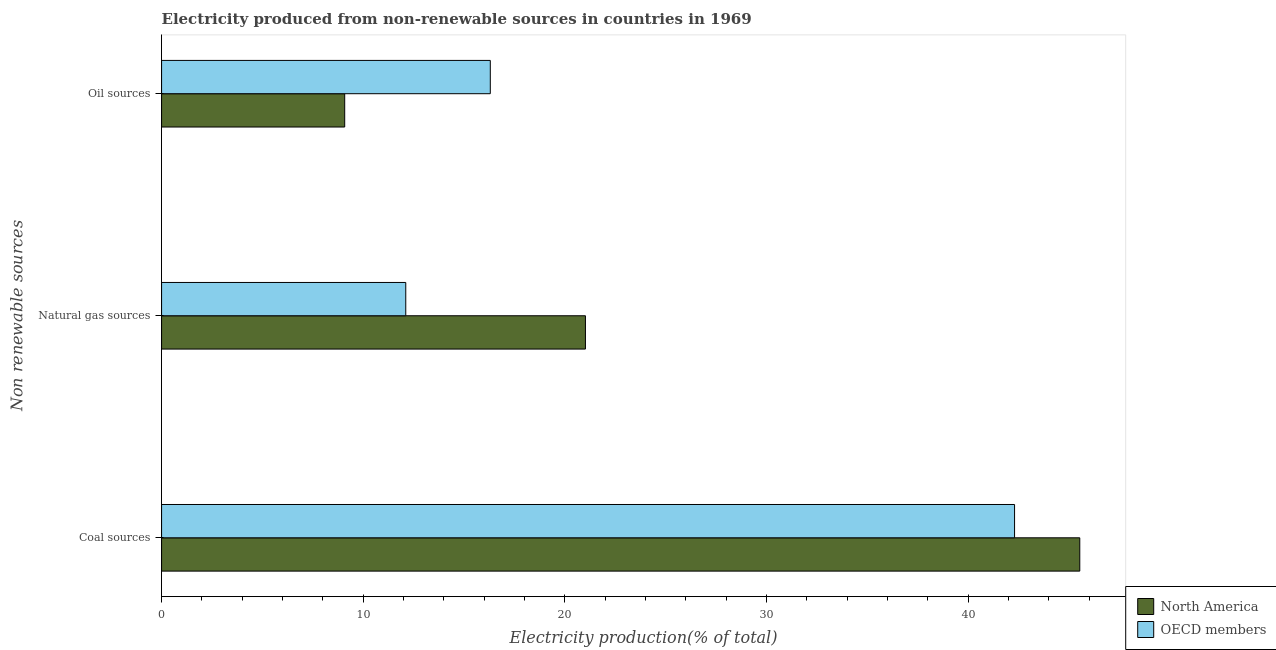How many groups of bars are there?
Offer a terse response. 3. What is the label of the 3rd group of bars from the top?
Offer a terse response. Coal sources. What is the percentage of electricity produced by oil sources in OECD members?
Make the answer very short. 16.3. Across all countries, what is the maximum percentage of electricity produced by coal?
Keep it short and to the point. 45.53. Across all countries, what is the minimum percentage of electricity produced by oil sources?
Make the answer very short. 9.08. What is the total percentage of electricity produced by oil sources in the graph?
Ensure brevity in your answer.  25.38. What is the difference between the percentage of electricity produced by oil sources in North America and that in OECD members?
Your response must be concise. -7.22. What is the difference between the percentage of electricity produced by oil sources in OECD members and the percentage of electricity produced by natural gas in North America?
Provide a short and direct response. -4.72. What is the average percentage of electricity produced by natural gas per country?
Give a very brief answer. 16.56. What is the difference between the percentage of electricity produced by oil sources and percentage of electricity produced by natural gas in OECD members?
Provide a short and direct response. 4.19. In how many countries, is the percentage of electricity produced by oil sources greater than 12 %?
Offer a very short reply. 1. What is the ratio of the percentage of electricity produced by oil sources in OECD members to that in North America?
Ensure brevity in your answer.  1.8. Is the percentage of electricity produced by coal in OECD members less than that in North America?
Ensure brevity in your answer.  Yes. What is the difference between the highest and the second highest percentage of electricity produced by coal?
Make the answer very short. 3.23. What is the difference between the highest and the lowest percentage of electricity produced by oil sources?
Your answer should be compact. 7.22. In how many countries, is the percentage of electricity produced by coal greater than the average percentage of electricity produced by coal taken over all countries?
Offer a terse response. 1. Is the sum of the percentage of electricity produced by oil sources in North America and OECD members greater than the maximum percentage of electricity produced by natural gas across all countries?
Offer a very short reply. Yes. What does the 1st bar from the top in Oil sources represents?
Your response must be concise. OECD members. How many bars are there?
Provide a succinct answer. 6. How many countries are there in the graph?
Your answer should be compact. 2. What is the difference between two consecutive major ticks on the X-axis?
Your answer should be very brief. 10. Does the graph contain grids?
Make the answer very short. No. Where does the legend appear in the graph?
Offer a terse response. Bottom right. How many legend labels are there?
Your answer should be compact. 2. What is the title of the graph?
Your response must be concise. Electricity produced from non-renewable sources in countries in 1969. Does "Central Europe" appear as one of the legend labels in the graph?
Give a very brief answer. No. What is the label or title of the X-axis?
Ensure brevity in your answer.  Electricity production(% of total). What is the label or title of the Y-axis?
Make the answer very short. Non renewable sources. What is the Electricity production(% of total) of North America in Coal sources?
Provide a short and direct response. 45.53. What is the Electricity production(% of total) in OECD members in Coal sources?
Keep it short and to the point. 42.3. What is the Electricity production(% of total) in North America in Natural gas sources?
Your answer should be very brief. 21.02. What is the Electricity production(% of total) of OECD members in Natural gas sources?
Make the answer very short. 12.11. What is the Electricity production(% of total) in North America in Oil sources?
Offer a terse response. 9.08. What is the Electricity production(% of total) of OECD members in Oil sources?
Make the answer very short. 16.3. Across all Non renewable sources, what is the maximum Electricity production(% of total) in North America?
Provide a succinct answer. 45.53. Across all Non renewable sources, what is the maximum Electricity production(% of total) of OECD members?
Give a very brief answer. 42.3. Across all Non renewable sources, what is the minimum Electricity production(% of total) of North America?
Ensure brevity in your answer.  9.08. Across all Non renewable sources, what is the minimum Electricity production(% of total) of OECD members?
Your answer should be very brief. 12.11. What is the total Electricity production(% of total) of North America in the graph?
Provide a succinct answer. 75.63. What is the total Electricity production(% of total) in OECD members in the graph?
Provide a succinct answer. 70.7. What is the difference between the Electricity production(% of total) in North America in Coal sources and that in Natural gas sources?
Offer a very short reply. 24.51. What is the difference between the Electricity production(% of total) in OECD members in Coal sources and that in Natural gas sources?
Make the answer very short. 30.19. What is the difference between the Electricity production(% of total) in North America in Coal sources and that in Oil sources?
Provide a succinct answer. 36.45. What is the difference between the Electricity production(% of total) in OECD members in Coal sources and that in Oil sources?
Your answer should be compact. 26. What is the difference between the Electricity production(% of total) in North America in Natural gas sources and that in Oil sources?
Provide a short and direct response. 11.94. What is the difference between the Electricity production(% of total) of OECD members in Natural gas sources and that in Oil sources?
Offer a terse response. -4.19. What is the difference between the Electricity production(% of total) of North America in Coal sources and the Electricity production(% of total) of OECD members in Natural gas sources?
Your answer should be compact. 33.42. What is the difference between the Electricity production(% of total) of North America in Coal sources and the Electricity production(% of total) of OECD members in Oil sources?
Offer a very short reply. 29.23. What is the difference between the Electricity production(% of total) in North America in Natural gas sources and the Electricity production(% of total) in OECD members in Oil sources?
Keep it short and to the point. 4.72. What is the average Electricity production(% of total) of North America per Non renewable sources?
Your response must be concise. 25.21. What is the average Electricity production(% of total) of OECD members per Non renewable sources?
Your response must be concise. 23.57. What is the difference between the Electricity production(% of total) of North America and Electricity production(% of total) of OECD members in Coal sources?
Offer a terse response. 3.23. What is the difference between the Electricity production(% of total) of North America and Electricity production(% of total) of OECD members in Natural gas sources?
Make the answer very short. 8.91. What is the difference between the Electricity production(% of total) of North America and Electricity production(% of total) of OECD members in Oil sources?
Your answer should be compact. -7.22. What is the ratio of the Electricity production(% of total) in North America in Coal sources to that in Natural gas sources?
Your response must be concise. 2.17. What is the ratio of the Electricity production(% of total) in OECD members in Coal sources to that in Natural gas sources?
Make the answer very short. 3.49. What is the ratio of the Electricity production(% of total) of North America in Coal sources to that in Oil sources?
Provide a short and direct response. 5.01. What is the ratio of the Electricity production(% of total) in OECD members in Coal sources to that in Oil sources?
Offer a very short reply. 2.59. What is the ratio of the Electricity production(% of total) of North America in Natural gas sources to that in Oil sources?
Your answer should be compact. 2.31. What is the ratio of the Electricity production(% of total) in OECD members in Natural gas sources to that in Oil sources?
Offer a very short reply. 0.74. What is the difference between the highest and the second highest Electricity production(% of total) in North America?
Your answer should be compact. 24.51. What is the difference between the highest and the second highest Electricity production(% of total) in OECD members?
Your answer should be compact. 26. What is the difference between the highest and the lowest Electricity production(% of total) of North America?
Your answer should be compact. 36.45. What is the difference between the highest and the lowest Electricity production(% of total) of OECD members?
Offer a very short reply. 30.19. 